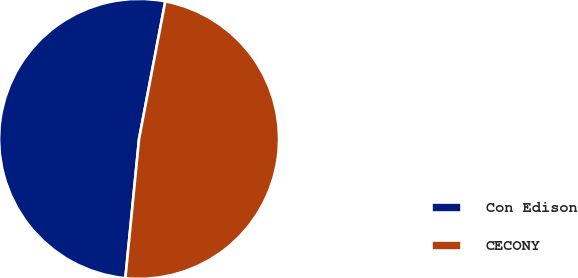Convert chart. <chart><loc_0><loc_0><loc_500><loc_500><pie_chart><fcel>Con Edison<fcel>CECONY<nl><fcel>51.44%<fcel>48.56%<nl></chart> 